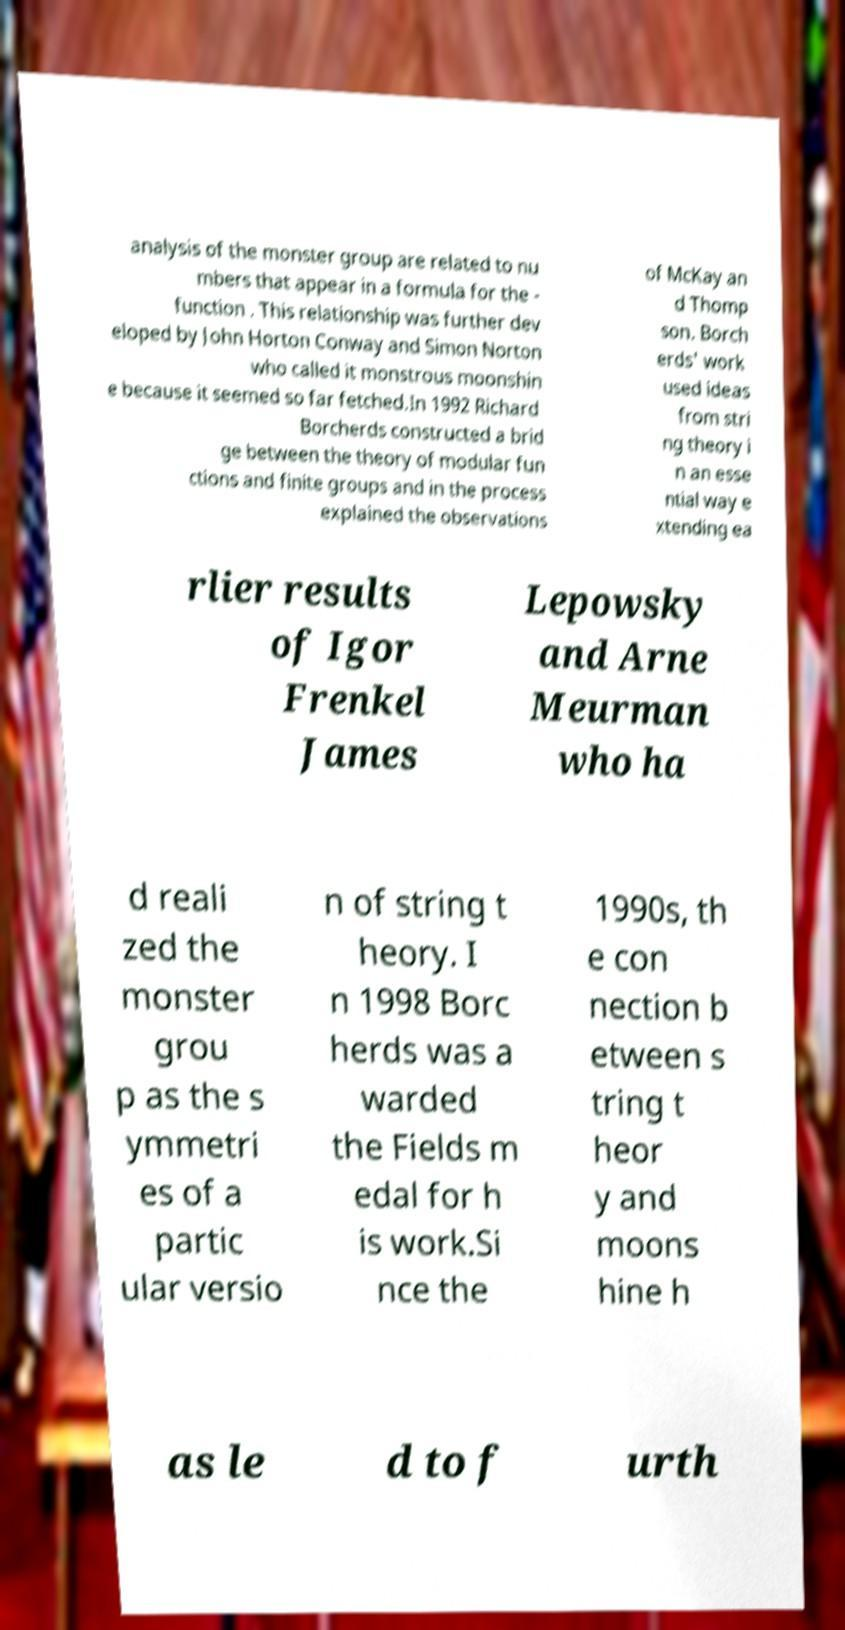Could you extract and type out the text from this image? analysis of the monster group are related to nu mbers that appear in a formula for the - function . This relationship was further dev eloped by John Horton Conway and Simon Norton who called it monstrous moonshin e because it seemed so far fetched.In 1992 Richard Borcherds constructed a brid ge between the theory of modular fun ctions and finite groups and in the process explained the observations of McKay an d Thomp son. Borch erds' work used ideas from stri ng theory i n an esse ntial way e xtending ea rlier results of Igor Frenkel James Lepowsky and Arne Meurman who ha d reali zed the monster grou p as the s ymmetri es of a partic ular versio n of string t heory. I n 1998 Borc herds was a warded the Fields m edal for h is work.Si nce the 1990s, th e con nection b etween s tring t heor y and moons hine h as le d to f urth 